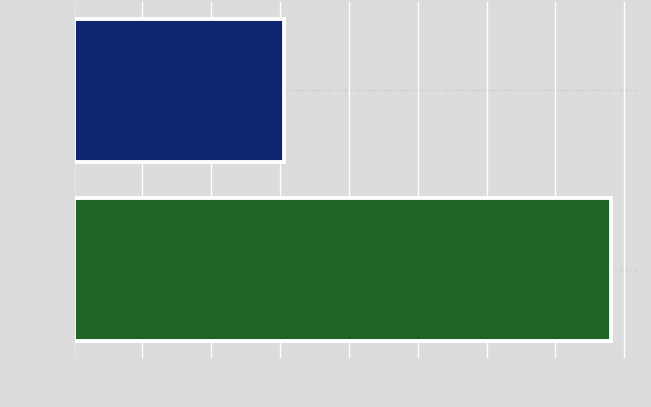Convert chart to OTSL. <chart><loc_0><loc_0><loc_500><loc_500><bar_chart><fcel>Trademarks with indefinite<fcel>Total intangible assets net<nl><fcel>76520<fcel>195244<nl></chart> 